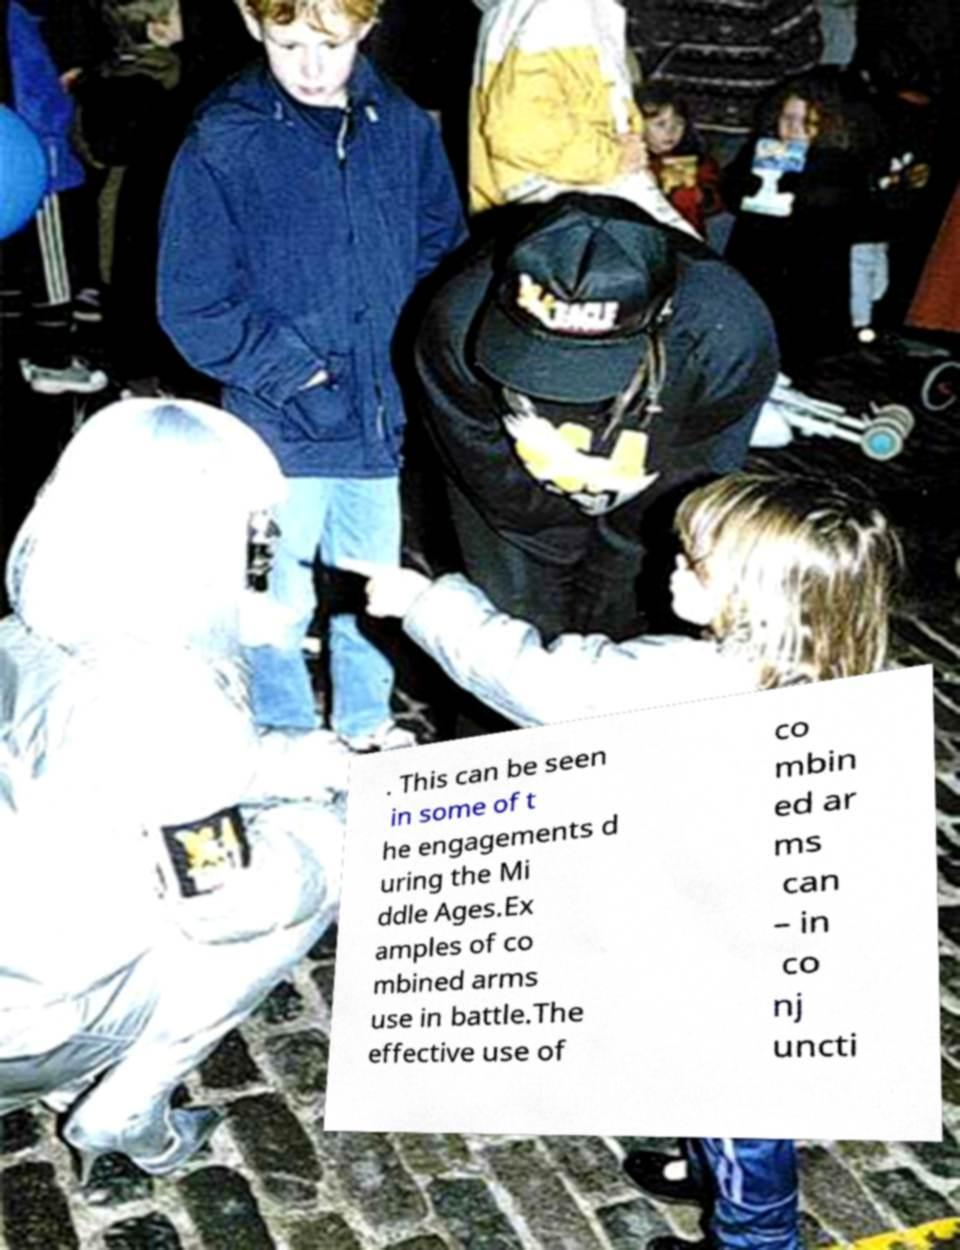Please read and relay the text visible in this image. What does it say? . This can be seen in some of t he engagements d uring the Mi ddle Ages.Ex amples of co mbined arms use in battle.The effective use of co mbin ed ar ms can – in co nj uncti 